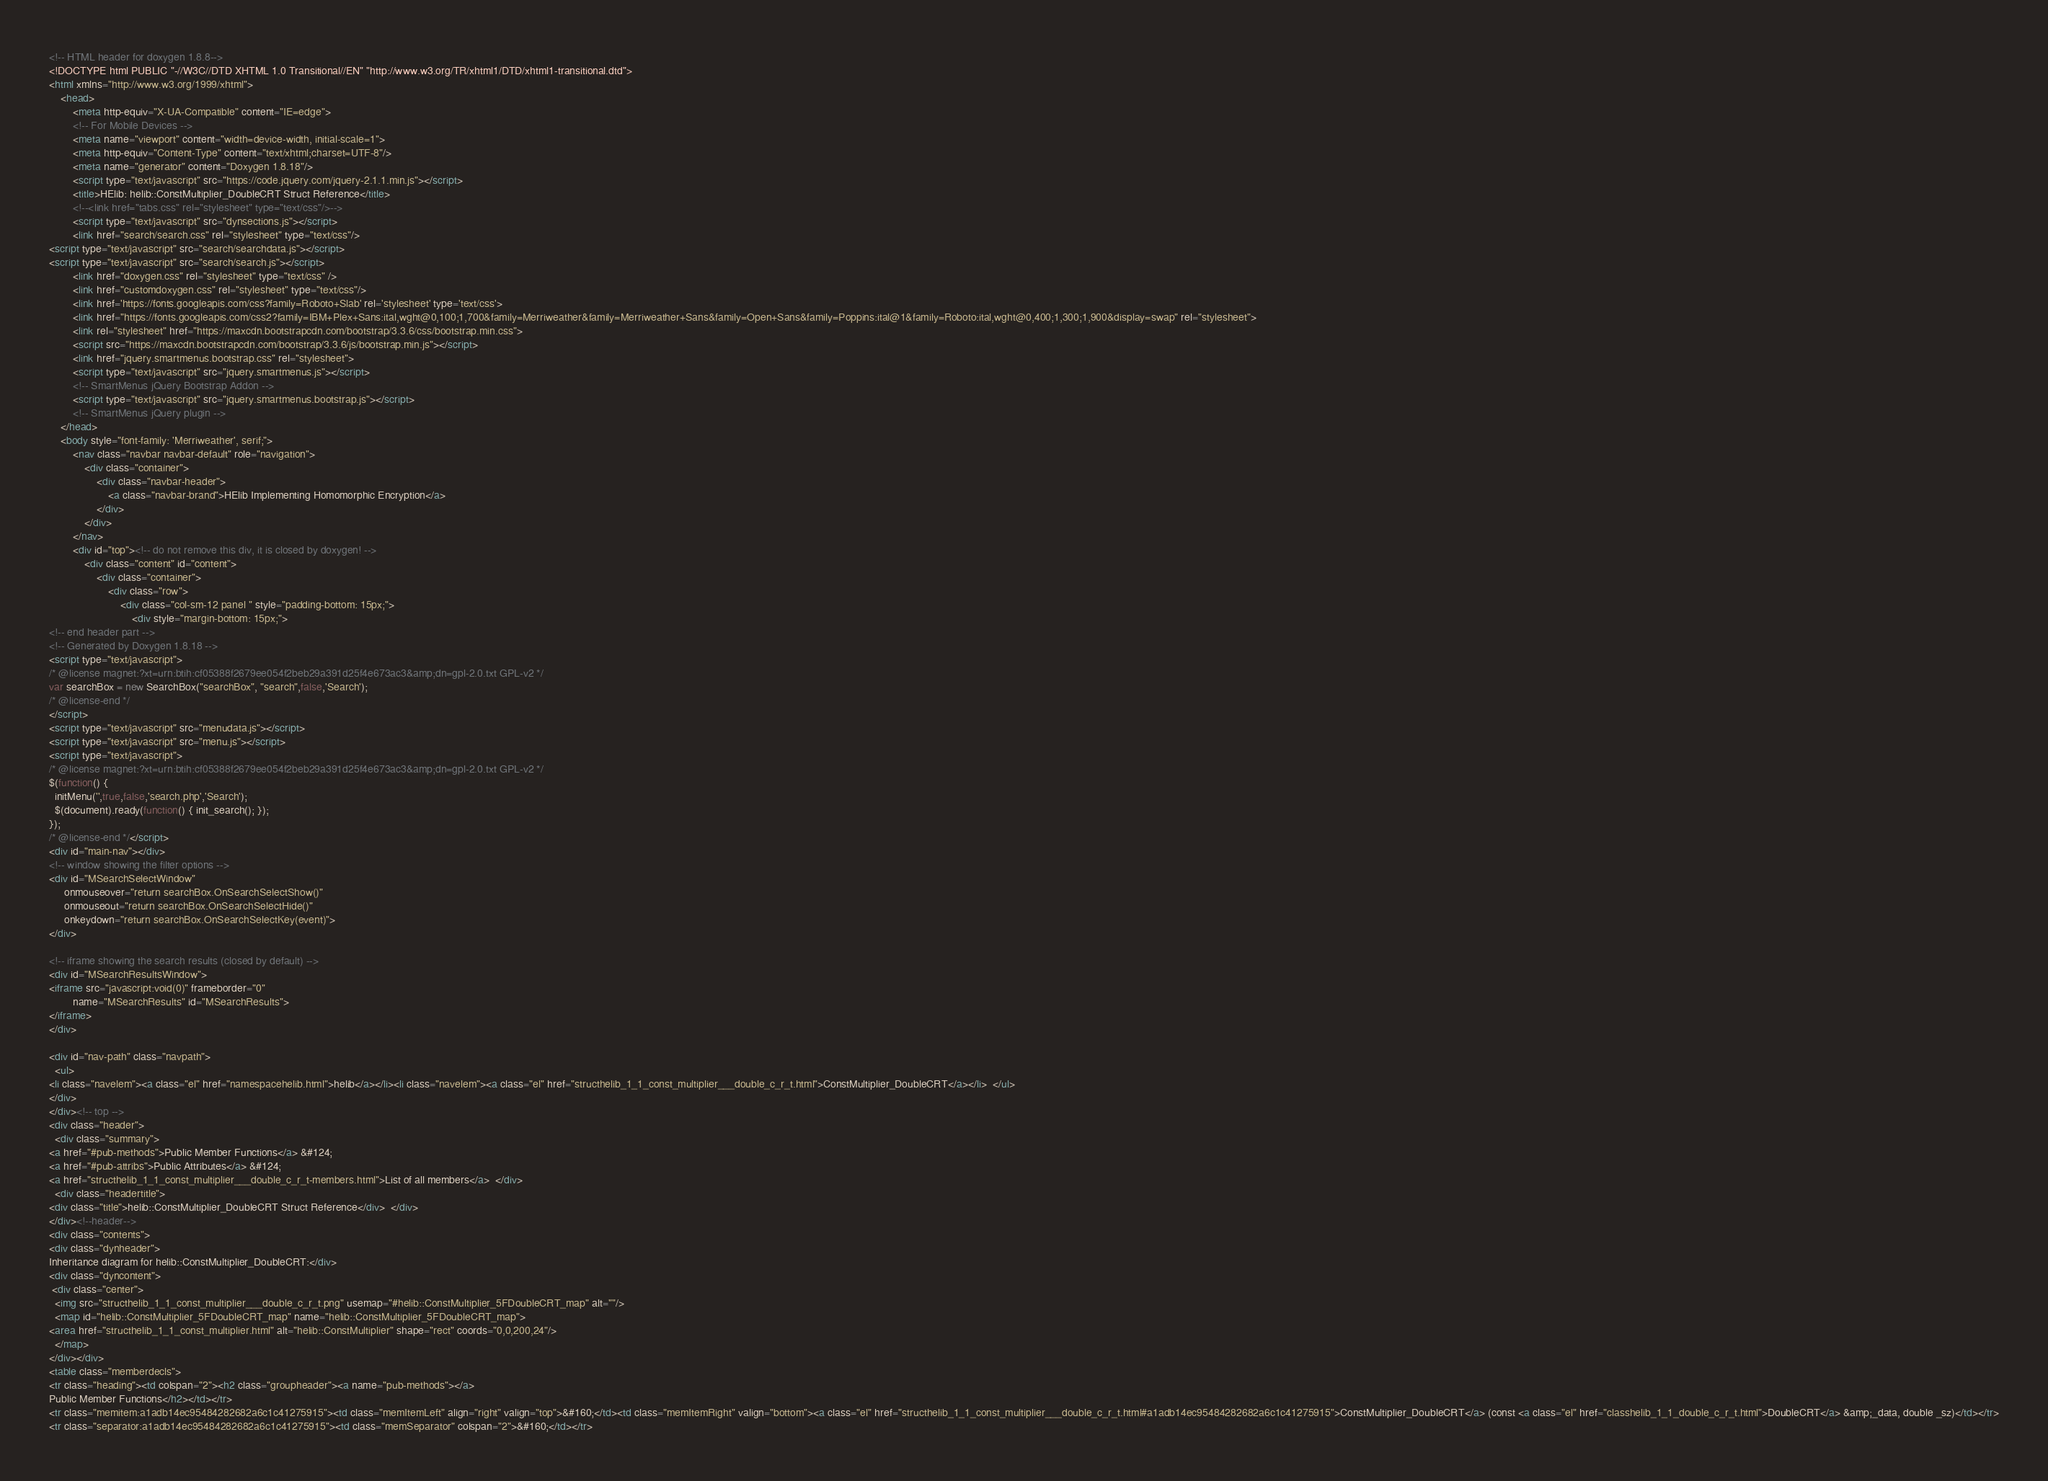Convert code to text. <code><loc_0><loc_0><loc_500><loc_500><_HTML_><!-- HTML header for doxygen 1.8.8-->
<!DOCTYPE html PUBLIC "-//W3C//DTD XHTML 1.0 Transitional//EN" "http://www.w3.org/TR/xhtml1/DTD/xhtml1-transitional.dtd">
<html xmlns="http://www.w3.org/1999/xhtml">
    <head>
        <meta http-equiv="X-UA-Compatible" content="IE=edge">
        <!-- For Mobile Devices -->
        <meta name="viewport" content="width=device-width, initial-scale=1">
        <meta http-equiv="Content-Type" content="text/xhtml;charset=UTF-8"/>
        <meta name="generator" content="Doxygen 1.8.18"/>
        <script type="text/javascript" src="https://code.jquery.com/jquery-2.1.1.min.js"></script>
        <title>HElib: helib::ConstMultiplier_DoubleCRT Struct Reference</title>
        <!--<link href="tabs.css" rel="stylesheet" type="text/css"/>-->
        <script type="text/javascript" src="dynsections.js"></script>
        <link href="search/search.css" rel="stylesheet" type="text/css"/>
<script type="text/javascript" src="search/searchdata.js"></script>
<script type="text/javascript" src="search/search.js"></script>
        <link href="doxygen.css" rel="stylesheet" type="text/css" />
        <link href="customdoxygen.css" rel="stylesheet" type="text/css"/>
        <link href='https://fonts.googleapis.com/css?family=Roboto+Slab' rel='stylesheet' type='text/css'>
		<link href="https://fonts.googleapis.com/css2?family=IBM+Plex+Sans:ital,wght@0,100;1,700&family=Merriweather&family=Merriweather+Sans&family=Open+Sans&family=Poppins:ital@1&family=Roboto:ital,wght@0,400;1,300;1,900&display=swap" rel="stylesheet"> 
        <link rel="stylesheet" href="https://maxcdn.bootstrapcdn.com/bootstrap/3.3.6/css/bootstrap.min.css">
        <script src="https://maxcdn.bootstrapcdn.com/bootstrap/3.3.6/js/bootstrap.min.js"></script>
        <link href="jquery.smartmenus.bootstrap.css" rel="stylesheet">
        <script type="text/javascript" src="jquery.smartmenus.js"></script>
        <!-- SmartMenus jQuery Bootstrap Addon -->
        <script type="text/javascript" src="jquery.smartmenus.bootstrap.js"></script>
        <!-- SmartMenus jQuery plugin -->
    </head>
    <body style="font-family: 'Merriweather', serif;">
        <nav class="navbar navbar-default" role="navigation">
            <div class="container">
                <div class="navbar-header">
                    <a class="navbar-brand">HElib Implementing Homomorphic Encryption</a>
                </div>
            </div>
        </nav>
        <div id="top"><!-- do not remove this div, it is closed by doxygen! -->
            <div class="content" id="content">
                <div class="container">
                    <div class="row">
                        <div class="col-sm-12 panel " style="padding-bottom: 15px;">
                            <div style="margin-bottom: 15px;">
<!-- end header part -->
<!-- Generated by Doxygen 1.8.18 -->
<script type="text/javascript">
/* @license magnet:?xt=urn:btih:cf05388f2679ee054f2beb29a391d25f4e673ac3&amp;dn=gpl-2.0.txt GPL-v2 */
var searchBox = new SearchBox("searchBox", "search",false,'Search');
/* @license-end */
</script>
<script type="text/javascript" src="menudata.js"></script>
<script type="text/javascript" src="menu.js"></script>
<script type="text/javascript">
/* @license magnet:?xt=urn:btih:cf05388f2679ee054f2beb29a391d25f4e673ac3&amp;dn=gpl-2.0.txt GPL-v2 */
$(function() {
  initMenu('',true,false,'search.php','Search');
  $(document).ready(function() { init_search(); });
});
/* @license-end */</script>
<div id="main-nav"></div>
<!-- window showing the filter options -->
<div id="MSearchSelectWindow"
     onmouseover="return searchBox.OnSearchSelectShow()"
     onmouseout="return searchBox.OnSearchSelectHide()"
     onkeydown="return searchBox.OnSearchSelectKey(event)">
</div>

<!-- iframe showing the search results (closed by default) -->
<div id="MSearchResultsWindow">
<iframe src="javascript:void(0)" frameborder="0" 
        name="MSearchResults" id="MSearchResults">
</iframe>
</div>

<div id="nav-path" class="navpath">
  <ul>
<li class="navelem"><a class="el" href="namespacehelib.html">helib</a></li><li class="navelem"><a class="el" href="structhelib_1_1_const_multiplier___double_c_r_t.html">ConstMultiplier_DoubleCRT</a></li>  </ul>
</div>
</div><!-- top -->
<div class="header">
  <div class="summary">
<a href="#pub-methods">Public Member Functions</a> &#124;
<a href="#pub-attribs">Public Attributes</a> &#124;
<a href="structhelib_1_1_const_multiplier___double_c_r_t-members.html">List of all members</a>  </div>
  <div class="headertitle">
<div class="title">helib::ConstMultiplier_DoubleCRT Struct Reference</div>  </div>
</div><!--header-->
<div class="contents">
<div class="dynheader">
Inheritance diagram for helib::ConstMultiplier_DoubleCRT:</div>
<div class="dyncontent">
 <div class="center">
  <img src="structhelib_1_1_const_multiplier___double_c_r_t.png" usemap="#helib::ConstMultiplier_5FDoubleCRT_map" alt=""/>
  <map id="helib::ConstMultiplier_5FDoubleCRT_map" name="helib::ConstMultiplier_5FDoubleCRT_map">
<area href="structhelib_1_1_const_multiplier.html" alt="helib::ConstMultiplier" shape="rect" coords="0,0,200,24"/>
  </map>
</div></div>
<table class="memberdecls">
<tr class="heading"><td colspan="2"><h2 class="groupheader"><a name="pub-methods"></a>
Public Member Functions</h2></td></tr>
<tr class="memitem:a1adb14ec95484282682a6c1c41275915"><td class="memItemLeft" align="right" valign="top">&#160;</td><td class="memItemRight" valign="bottom"><a class="el" href="structhelib_1_1_const_multiplier___double_c_r_t.html#a1adb14ec95484282682a6c1c41275915">ConstMultiplier_DoubleCRT</a> (const <a class="el" href="classhelib_1_1_double_c_r_t.html">DoubleCRT</a> &amp;_data, double _sz)</td></tr>
<tr class="separator:a1adb14ec95484282682a6c1c41275915"><td class="memSeparator" colspan="2">&#160;</td></tr></code> 